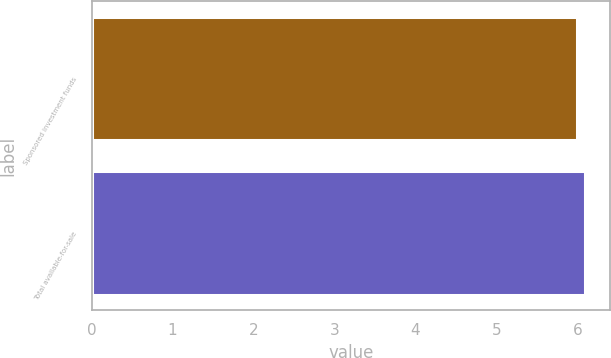Convert chart to OTSL. <chart><loc_0><loc_0><loc_500><loc_500><bar_chart><fcel>Sponsored investment funds<fcel>Total available-for-sale<nl><fcel>6<fcel>6.1<nl></chart> 